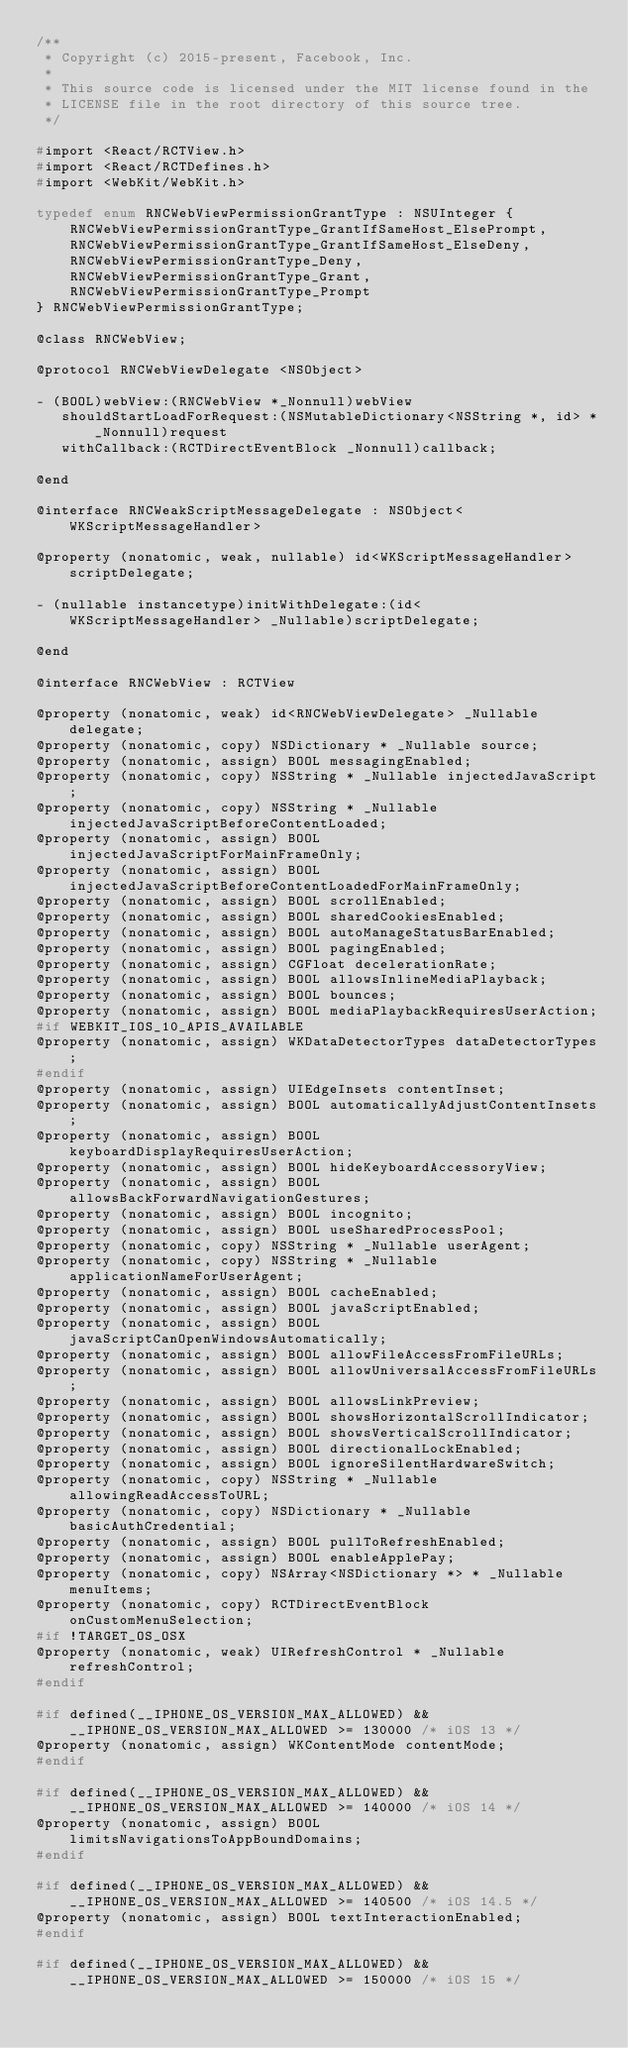<code> <loc_0><loc_0><loc_500><loc_500><_C_>/**
 * Copyright (c) 2015-present, Facebook, Inc.
 *
 * This source code is licensed under the MIT license found in the
 * LICENSE file in the root directory of this source tree.
 */

#import <React/RCTView.h>
#import <React/RCTDefines.h>
#import <WebKit/WebKit.h>

typedef enum RNCWebViewPermissionGrantType : NSUInteger {
    RNCWebViewPermissionGrantType_GrantIfSameHost_ElsePrompt,
    RNCWebViewPermissionGrantType_GrantIfSameHost_ElseDeny,
    RNCWebViewPermissionGrantType_Deny,
    RNCWebViewPermissionGrantType_Grant,
    RNCWebViewPermissionGrantType_Prompt
} RNCWebViewPermissionGrantType;

@class RNCWebView;

@protocol RNCWebViewDelegate <NSObject>

- (BOOL)webView:(RNCWebView *_Nonnull)webView
   shouldStartLoadForRequest:(NSMutableDictionary<NSString *, id> *_Nonnull)request
   withCallback:(RCTDirectEventBlock _Nonnull)callback;

@end

@interface RNCWeakScriptMessageDelegate : NSObject<WKScriptMessageHandler>

@property (nonatomic, weak, nullable) id<WKScriptMessageHandler> scriptDelegate;

- (nullable instancetype)initWithDelegate:(id<WKScriptMessageHandler> _Nullable)scriptDelegate;

@end

@interface RNCWebView : RCTView

@property (nonatomic, weak) id<RNCWebViewDelegate> _Nullable delegate;
@property (nonatomic, copy) NSDictionary * _Nullable source;
@property (nonatomic, assign) BOOL messagingEnabled;
@property (nonatomic, copy) NSString * _Nullable injectedJavaScript;
@property (nonatomic, copy) NSString * _Nullable injectedJavaScriptBeforeContentLoaded;
@property (nonatomic, assign) BOOL injectedJavaScriptForMainFrameOnly;
@property (nonatomic, assign) BOOL injectedJavaScriptBeforeContentLoadedForMainFrameOnly;
@property (nonatomic, assign) BOOL scrollEnabled;
@property (nonatomic, assign) BOOL sharedCookiesEnabled;
@property (nonatomic, assign) BOOL autoManageStatusBarEnabled;
@property (nonatomic, assign) BOOL pagingEnabled;
@property (nonatomic, assign) CGFloat decelerationRate;
@property (nonatomic, assign) BOOL allowsInlineMediaPlayback;
@property (nonatomic, assign) BOOL bounces;
@property (nonatomic, assign) BOOL mediaPlaybackRequiresUserAction;
#if WEBKIT_IOS_10_APIS_AVAILABLE
@property (nonatomic, assign) WKDataDetectorTypes dataDetectorTypes;
#endif
@property (nonatomic, assign) UIEdgeInsets contentInset;
@property (nonatomic, assign) BOOL automaticallyAdjustContentInsets;
@property (nonatomic, assign) BOOL keyboardDisplayRequiresUserAction;
@property (nonatomic, assign) BOOL hideKeyboardAccessoryView;
@property (nonatomic, assign) BOOL allowsBackForwardNavigationGestures;
@property (nonatomic, assign) BOOL incognito;
@property (nonatomic, assign) BOOL useSharedProcessPool;
@property (nonatomic, copy) NSString * _Nullable userAgent;
@property (nonatomic, copy) NSString * _Nullable applicationNameForUserAgent;
@property (nonatomic, assign) BOOL cacheEnabled;
@property (nonatomic, assign) BOOL javaScriptEnabled;
@property (nonatomic, assign) BOOL javaScriptCanOpenWindowsAutomatically;
@property (nonatomic, assign) BOOL allowFileAccessFromFileURLs;
@property (nonatomic, assign) BOOL allowUniversalAccessFromFileURLs;
@property (nonatomic, assign) BOOL allowsLinkPreview;
@property (nonatomic, assign) BOOL showsHorizontalScrollIndicator;
@property (nonatomic, assign) BOOL showsVerticalScrollIndicator;
@property (nonatomic, assign) BOOL directionalLockEnabled;
@property (nonatomic, assign) BOOL ignoreSilentHardwareSwitch;
@property (nonatomic, copy) NSString * _Nullable allowingReadAccessToURL;
@property (nonatomic, copy) NSDictionary * _Nullable basicAuthCredential;
@property (nonatomic, assign) BOOL pullToRefreshEnabled;
@property (nonatomic, assign) BOOL enableApplePay;
@property (nonatomic, copy) NSArray<NSDictionary *> * _Nullable menuItems;
@property (nonatomic, copy) RCTDirectEventBlock onCustomMenuSelection;
#if !TARGET_OS_OSX
@property (nonatomic, weak) UIRefreshControl * _Nullable refreshControl;
#endif

#if defined(__IPHONE_OS_VERSION_MAX_ALLOWED) && __IPHONE_OS_VERSION_MAX_ALLOWED >= 130000 /* iOS 13 */
@property (nonatomic, assign) WKContentMode contentMode;
#endif

#if defined(__IPHONE_OS_VERSION_MAX_ALLOWED) && __IPHONE_OS_VERSION_MAX_ALLOWED >= 140000 /* iOS 14 */
@property (nonatomic, assign) BOOL limitsNavigationsToAppBoundDomains;
#endif

#if defined(__IPHONE_OS_VERSION_MAX_ALLOWED) && __IPHONE_OS_VERSION_MAX_ALLOWED >= 140500 /* iOS 14.5 */
@property (nonatomic, assign) BOOL textInteractionEnabled;
#endif

#if defined(__IPHONE_OS_VERSION_MAX_ALLOWED) && __IPHONE_OS_VERSION_MAX_ALLOWED >= 150000 /* iOS 15 */</code> 